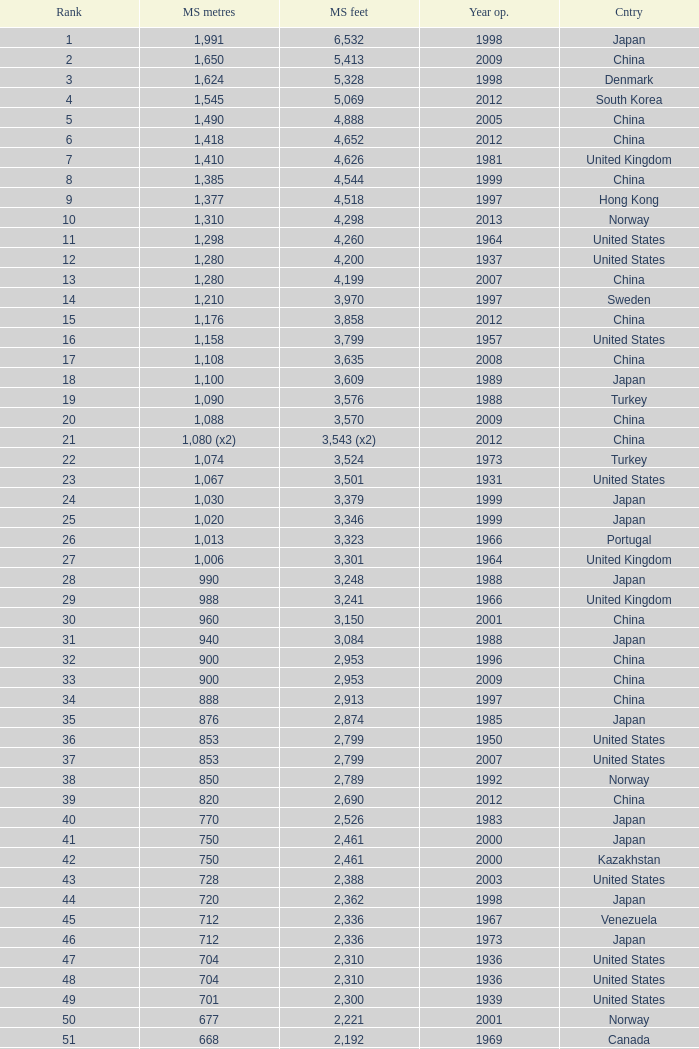What is the oldest year with a main span feet of 1,640 in South Korea? 2002.0. 